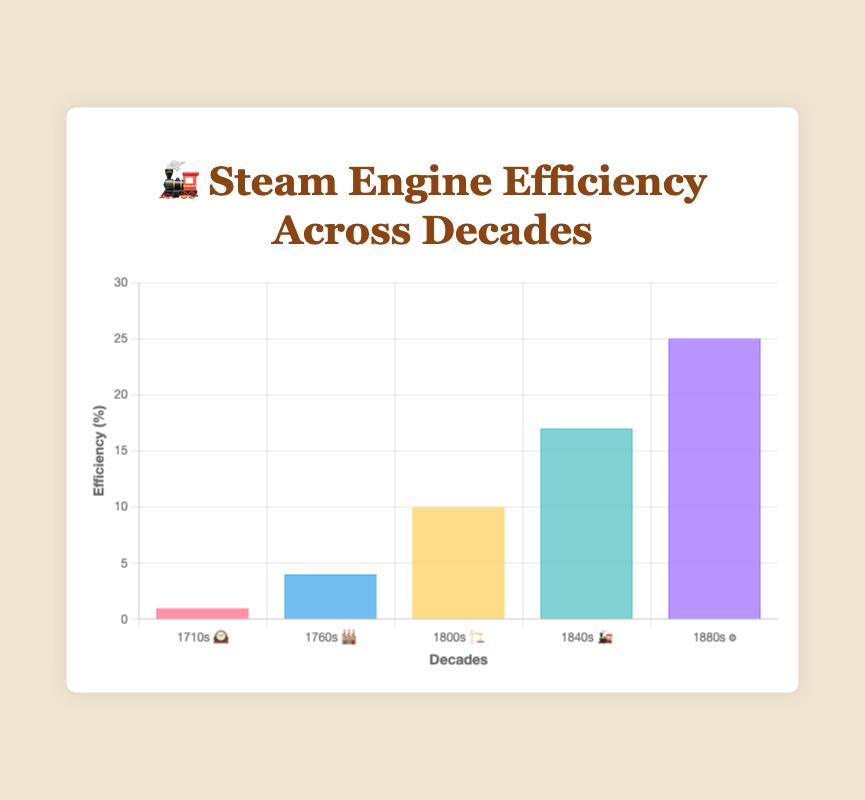What is the title of the figure? The figure has a clearly labeled title at the top center which reads "🚂 Steam Engine Efficiency Across Decades"
Answer: 🚂 Steam Engine Efficiency Across Decades How many decades are represented in the figure? By counting the number of labels on the x-axis, which correspond to the decades, we observe that there are five labels: "1710s 🕰️", "1760s 🏭", "1800s 🏗️", "1840s 🚂", and "1880s ⚙️"
Answer: 5 What is the efficiency percentage for the 1800s? The bar corresponding to the "1800s 🏗️" reaches up to the 10% mark on the y-axis, showing that the efficiency percentage for the 1800s is 10%.
Answer: 10% Which decade saw the highest efficiency improvement? The tallest bar on the graph, which represents the highest efficiency, is for the "1880s ⚙️", indicating that this decade saw the highest efficiency improvement.
Answer: 1880s ⚙️ Which notable engine is associated with the 1760s? According to the visual tooltip provided in the chart, the notable engine for the "1760s 🏭" is the Watt Engine with the emoji 🔥
Answer: Watt Engine 🔥 By how much did the efficiency percentage increase from the 1710s to the 1840s? To calculate the increase, subtract the efficiency of the 1710s (1%) from the efficiency of the 1840s (17%). The difference is 17% - 1% = 16%.
Answer: 16% What is the average efficiency percentage across all the decades shown? To find the average, sum all the efficiency percentages (1 + 4 + 10 + 17 + 25) = 57, then divide by the number of decades (5). The average is 57 / 5 = 11.4%.
Answer: 11.4% Which decade had an efficiency improvement of more than double from the previous notable engine? Comparing the efficiency values, from the 1760s (4%) to the 1800s (10%), the increase is more than double as 10% is more than 2*4% = 8%. Hence, the 1800s represents this improvement.
Answer: 1800s 🏗️ What is the range of the efficiency percentages displayed in the figure? The efficiency range is calculated by subtracting the minimum percentage (1% in the 1710s) from the maximum percentage (25% in the 1880s), resulting in 25% - 1% = 24%.
Answer: 24% What color represents the efficiency for the 1840s and what is its efficiency percentage? The color representing the 1840s is a shade of teal (rgba(75, 192, 192, 0.7)) and the corresponding efficiency percentage is 17%.
Answer: Teal, 17% 